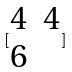Convert formula to latex. <formula><loc_0><loc_0><loc_500><loc_500>[ \begin{matrix} 4 & 4 \\ 6 \end{matrix} ]</formula> 